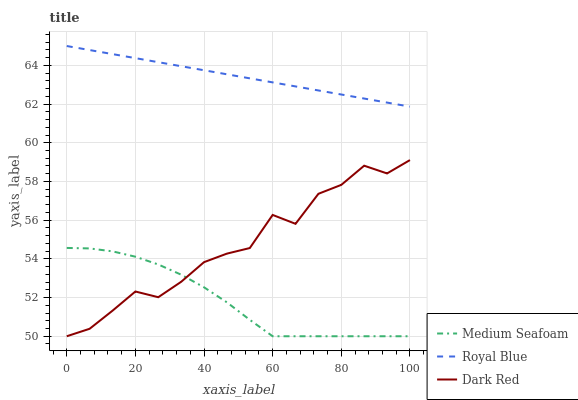Does Medium Seafoam have the minimum area under the curve?
Answer yes or no. Yes. Does Royal Blue have the maximum area under the curve?
Answer yes or no. Yes. Does Dark Red have the minimum area under the curve?
Answer yes or no. No. Does Dark Red have the maximum area under the curve?
Answer yes or no. No. Is Royal Blue the smoothest?
Answer yes or no. Yes. Is Dark Red the roughest?
Answer yes or no. Yes. Is Medium Seafoam the smoothest?
Answer yes or no. No. Is Medium Seafoam the roughest?
Answer yes or no. No. Does Medium Seafoam have the lowest value?
Answer yes or no. Yes. Does Royal Blue have the highest value?
Answer yes or no. Yes. Does Dark Red have the highest value?
Answer yes or no. No. Is Dark Red less than Royal Blue?
Answer yes or no. Yes. Is Royal Blue greater than Medium Seafoam?
Answer yes or no. Yes. Does Dark Red intersect Medium Seafoam?
Answer yes or no. Yes. Is Dark Red less than Medium Seafoam?
Answer yes or no. No. Is Dark Red greater than Medium Seafoam?
Answer yes or no. No. Does Dark Red intersect Royal Blue?
Answer yes or no. No. 